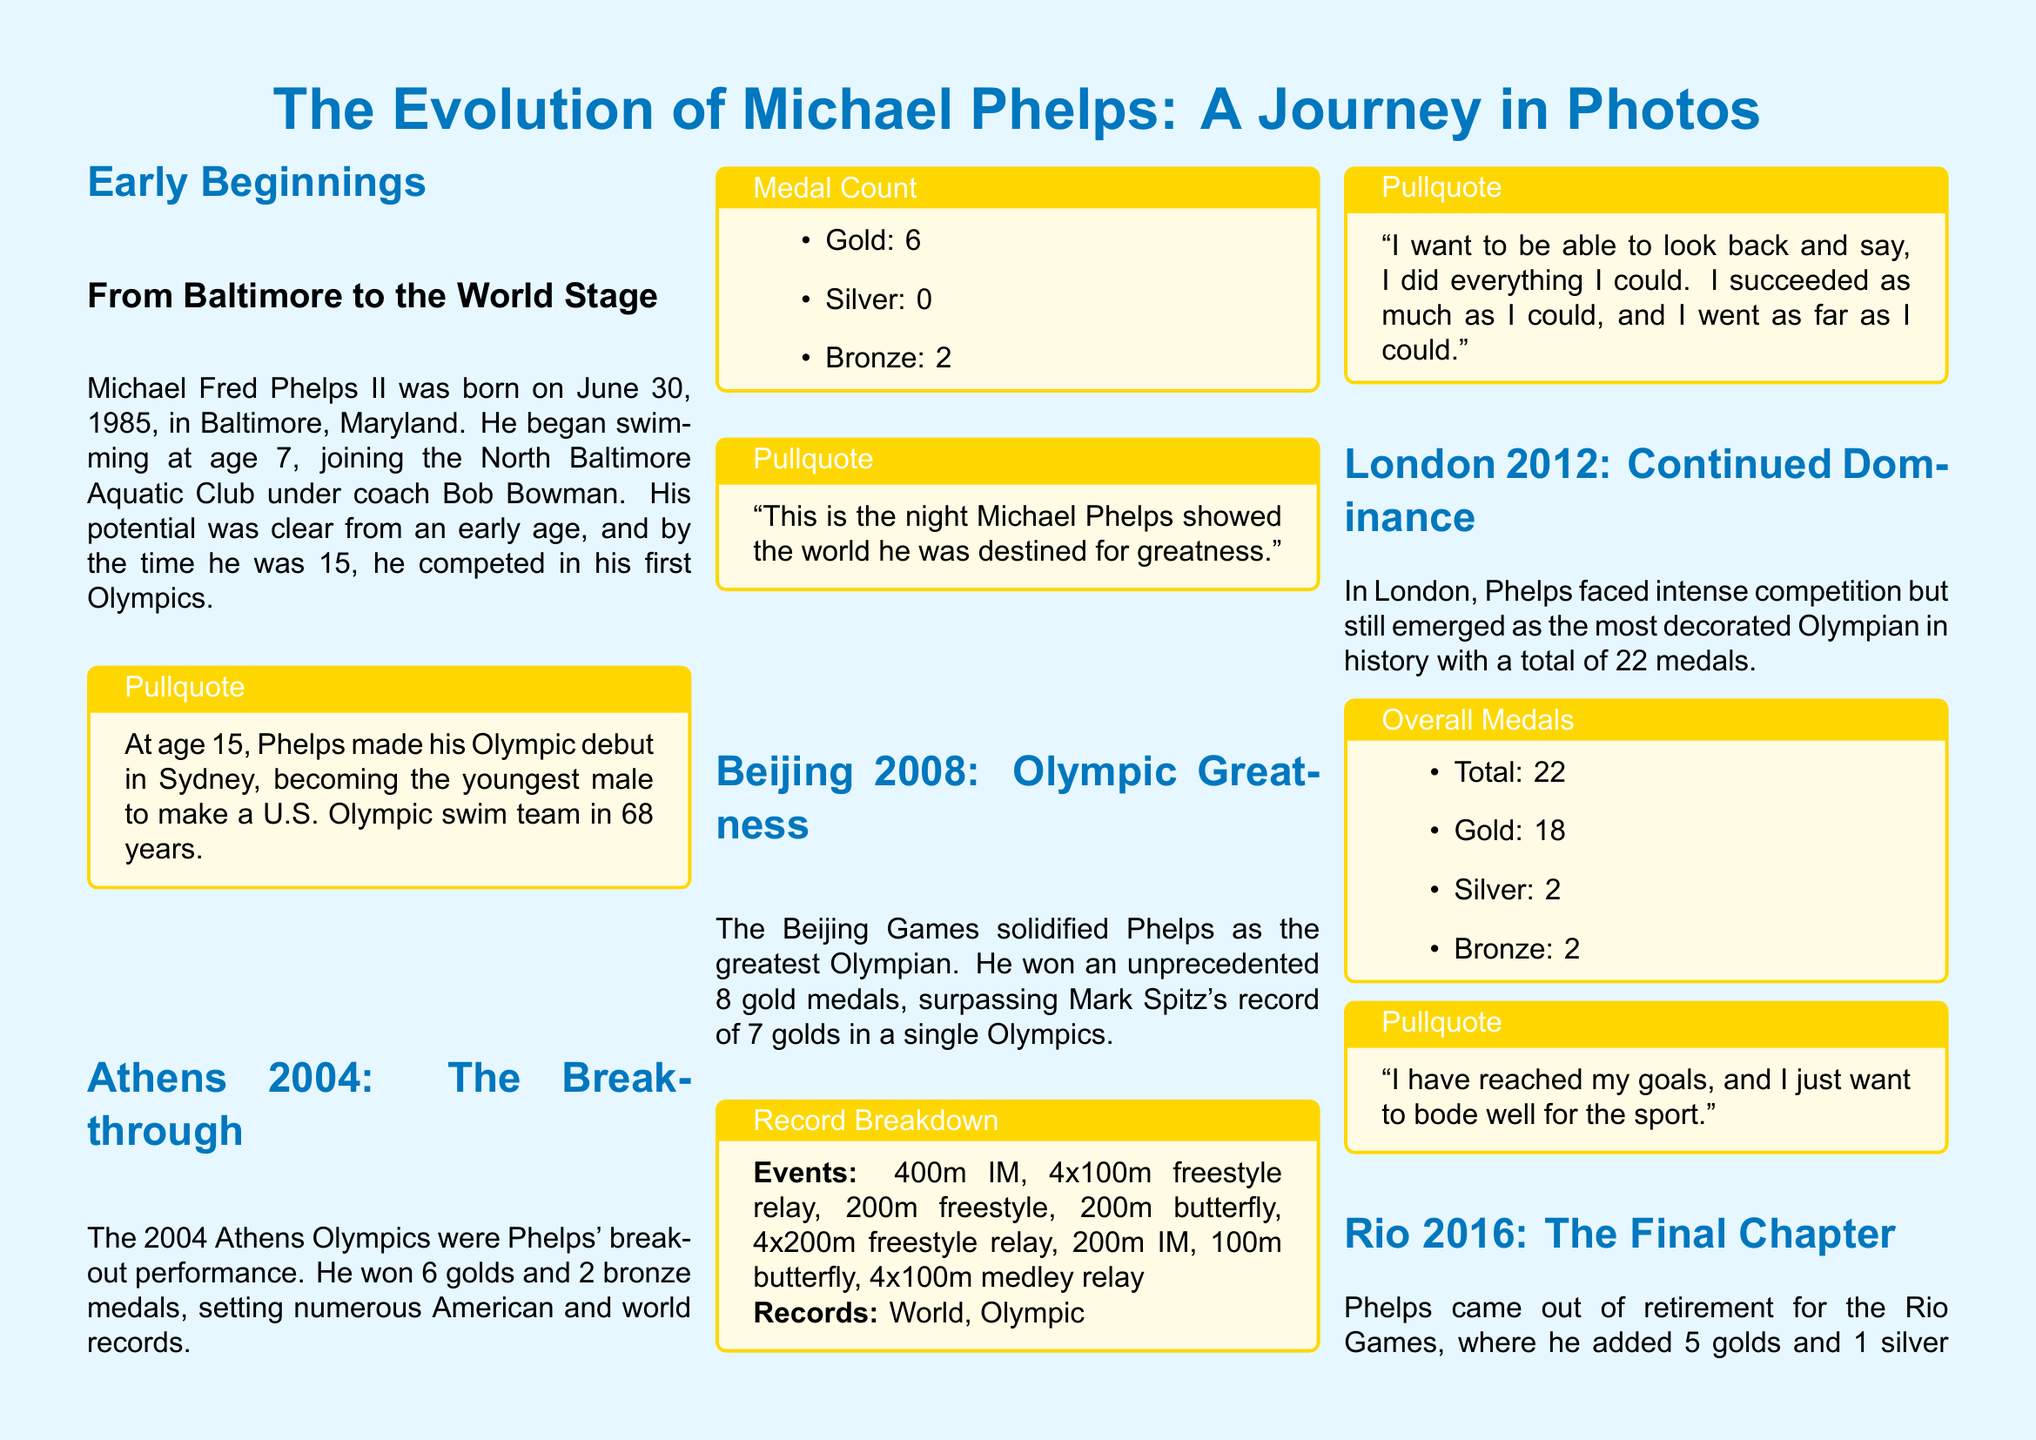What year did Michael Phelps make his Olympic debut? The document states he made his debut at age 15 in Sydney, which was in the year 2000.
Answer: 2000 How many gold medals did Phelps win in Athens 2004? The medal count in the document specifies that he won 6 gold medals in the 2004 Athens Olympics.
Answer: 6 What is Michael Phelps' total medal count at the end of his career? The document summarizes his total medals as 28 at the end of his Olympic career.
Answer: 28 Which event did Phelps not compete in during the Beijing 2008 Olympics? The document lists all events he participated in, and the 50m freestyle is not mentioned, indicating he did not compete in it.
Answer: 50m freestyle What was a significant achievement of Michael Phelps in the Beijing 2008 Olympics? The document notes that he won an unprecedented 8 gold medals in Beijing, which surpassed Mark Spitz's record.
Answer: 8 gold medals What was the total number of gold medals Michael Phelps won across all Olympics? According to the document, the overall total is 23 gold medals.
Answer: 23 In which year did Phelps retire after the Rio Olympics? The document states that Rio was the final chapter of his career, after which he stated, “I am done.”
Answer: 2016 What notable pullquote is associated with Phelps’ performance in Athens 2004? The document highlights a significant comment about Phelps’ breakthrough performance: "This is the night Michael Phelps showed the world he was destined for greatness."
Answer: "This is the night Michael Phelps showed the world he was destined for greatness." 